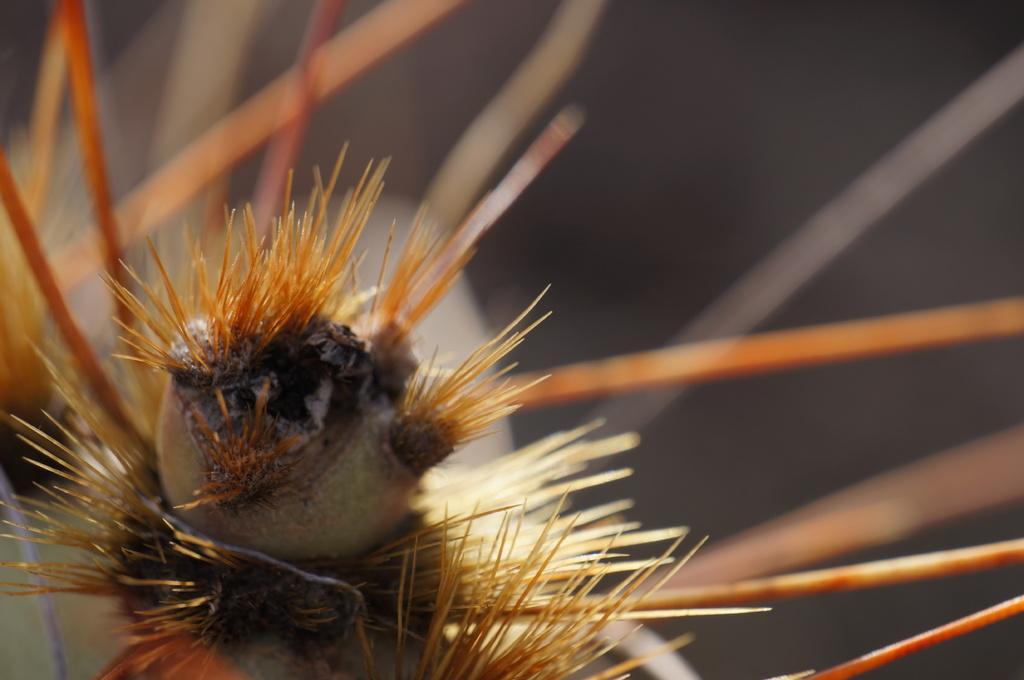In one or two sentences, can you explain what this image depicts? In this image I can see a spiky plant like object. This is a macro photography of a spiky plant and the background is blurred. 